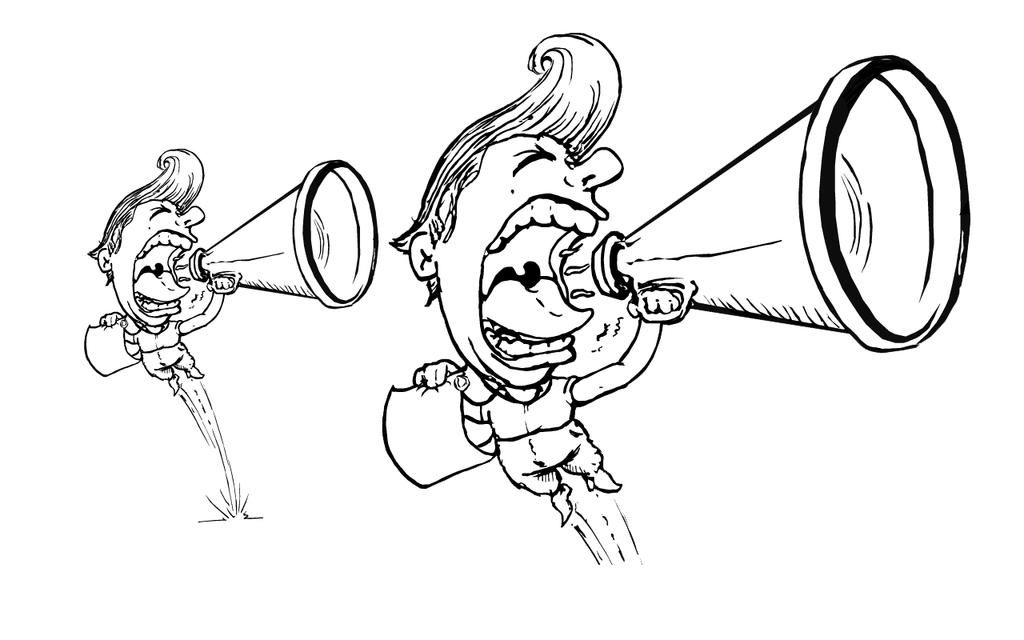What is the main subject of the image? There is a cartoon man in the image. What is the cartoon man holding in his hands? The cartoon man is holding a loudspeaker and a paper. What is the cartoon man doing in the image? The cartoon man is shouting. What is the color of the background in the image? The background of the image is white. What type of chalk is the cartoon man using to write on the blackboard in the image? There is no blackboard or chalk present in the image. What is the cartoon man learning in the image? The image does not depict the cartoon man learning anything; he is shouting with a loudspeaker and holding a paper. 